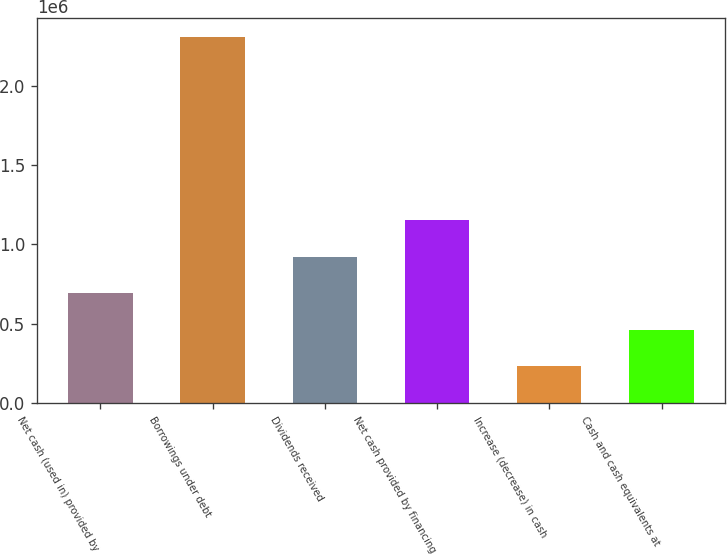Convert chart. <chart><loc_0><loc_0><loc_500><loc_500><bar_chart><fcel>Net cash (used in) provided by<fcel>Borrowings under debt<fcel>Dividends received<fcel>Net cash provided by financing<fcel>Increase (decrease) in cash<fcel>Cash and cash equivalents at<nl><fcel>692714<fcel>2.309e+06<fcel>923612<fcel>1.15451e+06<fcel>230918<fcel>461816<nl></chart> 